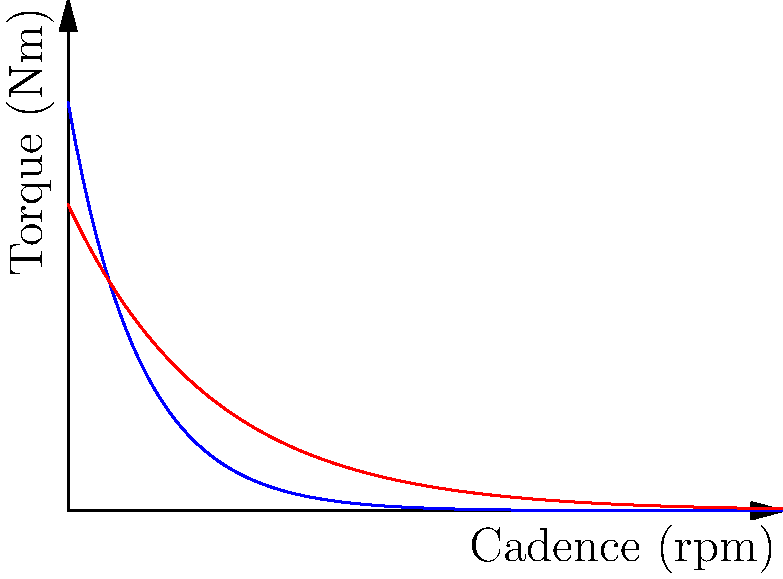As an innovative bike manufacturer, you're designing a new foldable bicycle for urban commuters. The graph shows torque curves for two different gear ratios across various cadences. Gear Ratio 1 (blue) has an initial torque of 20 Nm and decays at a rate of 10% per 10 rpm. Gear Ratio 2 (red) starts at 15 Nm and decays at 5% per 10 rpm. At what cadence (in rpm) do both gear ratios produce the same torque? Round your answer to the nearest whole number. To solve this problem, we need to follow these steps:

1) First, let's write equations for each torque curve:
   Gear Ratio 1: $T_1 = 20e^{-0.01x}$
   Gear Ratio 2: $T_2 = 15e^{-0.005x}$
   Where $x$ is the cadence in rpm.

2) At the intersection point, these torques are equal:
   $20e^{-0.01x} = 15e^{-0.005x}$

3) Taking the natural log of both sides:
   $\ln(20) - 0.01x = \ln(15) - 0.005x$

4) Simplify:
   $\ln(20) - \ln(15) = 0.01x - 0.005x = 0.005x$

5) Solve for x:
   $x = \frac{\ln(20) - \ln(15)}{0.005} = \frac{\ln(\frac{20}{15})}{0.005}$

6) Calculate:
   $x \approx 57.7$ rpm

7) Rounding to the nearest whole number:
   $x = 58$ rpm

Therefore, both gear ratios produce the same torque at approximately 58 rpm.
Answer: 58 rpm 